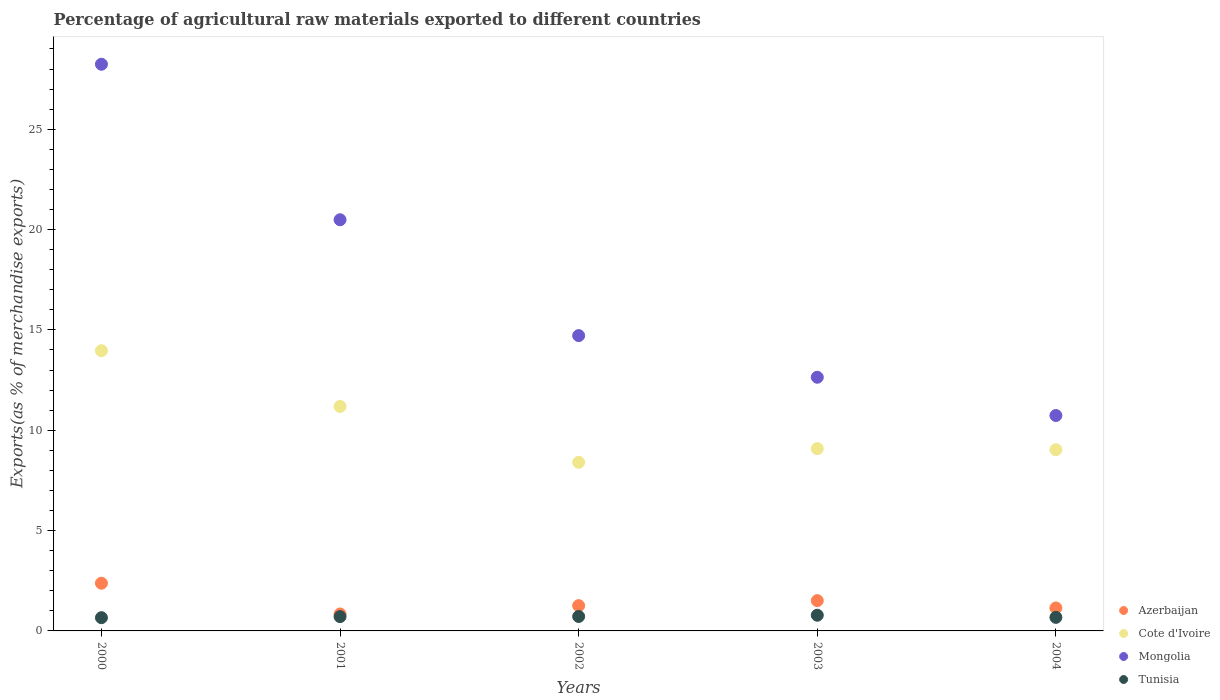How many different coloured dotlines are there?
Ensure brevity in your answer.  4. What is the percentage of exports to different countries in Tunisia in 2004?
Keep it short and to the point. 0.68. Across all years, what is the maximum percentage of exports to different countries in Azerbaijan?
Your response must be concise. 2.38. Across all years, what is the minimum percentage of exports to different countries in Tunisia?
Your answer should be compact. 0.66. What is the total percentage of exports to different countries in Cote d'Ivoire in the graph?
Give a very brief answer. 51.66. What is the difference between the percentage of exports to different countries in Azerbaijan in 2000 and that in 2003?
Ensure brevity in your answer.  0.87. What is the difference between the percentage of exports to different countries in Azerbaijan in 2001 and the percentage of exports to different countries in Cote d'Ivoire in 2000?
Ensure brevity in your answer.  -13.12. What is the average percentage of exports to different countries in Cote d'Ivoire per year?
Keep it short and to the point. 10.33. In the year 2001, what is the difference between the percentage of exports to different countries in Cote d'Ivoire and percentage of exports to different countries in Tunisia?
Ensure brevity in your answer.  10.47. What is the ratio of the percentage of exports to different countries in Cote d'Ivoire in 2002 to that in 2004?
Give a very brief answer. 0.93. Is the percentage of exports to different countries in Tunisia in 2000 less than that in 2003?
Provide a short and direct response. Yes. What is the difference between the highest and the second highest percentage of exports to different countries in Tunisia?
Provide a short and direct response. 0.06. What is the difference between the highest and the lowest percentage of exports to different countries in Cote d'Ivoire?
Give a very brief answer. 5.56. Is the sum of the percentage of exports to different countries in Tunisia in 2001 and 2004 greater than the maximum percentage of exports to different countries in Mongolia across all years?
Make the answer very short. No. Is it the case that in every year, the sum of the percentage of exports to different countries in Tunisia and percentage of exports to different countries in Cote d'Ivoire  is greater than the sum of percentage of exports to different countries in Mongolia and percentage of exports to different countries in Azerbaijan?
Make the answer very short. Yes. Is it the case that in every year, the sum of the percentage of exports to different countries in Cote d'Ivoire and percentage of exports to different countries in Mongolia  is greater than the percentage of exports to different countries in Tunisia?
Offer a terse response. Yes. How many dotlines are there?
Ensure brevity in your answer.  4. What is the difference between two consecutive major ticks on the Y-axis?
Your answer should be compact. 5. Does the graph contain any zero values?
Make the answer very short. No. Does the graph contain grids?
Make the answer very short. No. Where does the legend appear in the graph?
Keep it short and to the point. Bottom right. How many legend labels are there?
Your response must be concise. 4. What is the title of the graph?
Your answer should be very brief. Percentage of agricultural raw materials exported to different countries. Does "Czech Republic" appear as one of the legend labels in the graph?
Give a very brief answer. No. What is the label or title of the Y-axis?
Provide a succinct answer. Exports(as % of merchandise exports). What is the Exports(as % of merchandise exports) in Azerbaijan in 2000?
Provide a succinct answer. 2.38. What is the Exports(as % of merchandise exports) in Cote d'Ivoire in 2000?
Your answer should be very brief. 13.97. What is the Exports(as % of merchandise exports) of Mongolia in 2000?
Provide a succinct answer. 28.24. What is the Exports(as % of merchandise exports) in Tunisia in 2000?
Offer a very short reply. 0.66. What is the Exports(as % of merchandise exports) in Azerbaijan in 2001?
Give a very brief answer. 0.85. What is the Exports(as % of merchandise exports) of Cote d'Ivoire in 2001?
Provide a short and direct response. 11.18. What is the Exports(as % of merchandise exports) of Mongolia in 2001?
Ensure brevity in your answer.  20.49. What is the Exports(as % of merchandise exports) of Tunisia in 2001?
Provide a succinct answer. 0.71. What is the Exports(as % of merchandise exports) of Azerbaijan in 2002?
Your response must be concise. 1.26. What is the Exports(as % of merchandise exports) of Cote d'Ivoire in 2002?
Give a very brief answer. 8.4. What is the Exports(as % of merchandise exports) in Mongolia in 2002?
Give a very brief answer. 14.72. What is the Exports(as % of merchandise exports) of Tunisia in 2002?
Ensure brevity in your answer.  0.72. What is the Exports(as % of merchandise exports) in Azerbaijan in 2003?
Offer a very short reply. 1.51. What is the Exports(as % of merchandise exports) of Cote d'Ivoire in 2003?
Give a very brief answer. 9.08. What is the Exports(as % of merchandise exports) in Mongolia in 2003?
Keep it short and to the point. 12.64. What is the Exports(as % of merchandise exports) in Tunisia in 2003?
Offer a very short reply. 0.78. What is the Exports(as % of merchandise exports) in Azerbaijan in 2004?
Provide a short and direct response. 1.15. What is the Exports(as % of merchandise exports) in Cote d'Ivoire in 2004?
Make the answer very short. 9.03. What is the Exports(as % of merchandise exports) of Mongolia in 2004?
Your answer should be very brief. 10.73. What is the Exports(as % of merchandise exports) in Tunisia in 2004?
Make the answer very short. 0.68. Across all years, what is the maximum Exports(as % of merchandise exports) in Azerbaijan?
Keep it short and to the point. 2.38. Across all years, what is the maximum Exports(as % of merchandise exports) in Cote d'Ivoire?
Offer a very short reply. 13.97. Across all years, what is the maximum Exports(as % of merchandise exports) in Mongolia?
Offer a terse response. 28.24. Across all years, what is the maximum Exports(as % of merchandise exports) in Tunisia?
Your answer should be very brief. 0.78. Across all years, what is the minimum Exports(as % of merchandise exports) in Azerbaijan?
Your response must be concise. 0.85. Across all years, what is the minimum Exports(as % of merchandise exports) in Cote d'Ivoire?
Keep it short and to the point. 8.4. Across all years, what is the minimum Exports(as % of merchandise exports) of Mongolia?
Give a very brief answer. 10.73. Across all years, what is the minimum Exports(as % of merchandise exports) in Tunisia?
Your response must be concise. 0.66. What is the total Exports(as % of merchandise exports) of Azerbaijan in the graph?
Make the answer very short. 7.14. What is the total Exports(as % of merchandise exports) in Cote d'Ivoire in the graph?
Offer a very short reply. 51.66. What is the total Exports(as % of merchandise exports) of Mongolia in the graph?
Make the answer very short. 86.82. What is the total Exports(as % of merchandise exports) of Tunisia in the graph?
Ensure brevity in your answer.  3.55. What is the difference between the Exports(as % of merchandise exports) of Azerbaijan in 2000 and that in 2001?
Your response must be concise. 1.53. What is the difference between the Exports(as % of merchandise exports) of Cote d'Ivoire in 2000 and that in 2001?
Provide a succinct answer. 2.78. What is the difference between the Exports(as % of merchandise exports) of Mongolia in 2000 and that in 2001?
Offer a very short reply. 7.75. What is the difference between the Exports(as % of merchandise exports) of Tunisia in 2000 and that in 2001?
Your answer should be compact. -0.05. What is the difference between the Exports(as % of merchandise exports) of Azerbaijan in 2000 and that in 2002?
Offer a terse response. 1.12. What is the difference between the Exports(as % of merchandise exports) of Cote d'Ivoire in 2000 and that in 2002?
Keep it short and to the point. 5.56. What is the difference between the Exports(as % of merchandise exports) in Mongolia in 2000 and that in 2002?
Provide a succinct answer. 13.52. What is the difference between the Exports(as % of merchandise exports) in Tunisia in 2000 and that in 2002?
Ensure brevity in your answer.  -0.06. What is the difference between the Exports(as % of merchandise exports) of Azerbaijan in 2000 and that in 2003?
Keep it short and to the point. 0.87. What is the difference between the Exports(as % of merchandise exports) in Cote d'Ivoire in 2000 and that in 2003?
Your answer should be compact. 4.88. What is the difference between the Exports(as % of merchandise exports) of Mongolia in 2000 and that in 2003?
Keep it short and to the point. 15.6. What is the difference between the Exports(as % of merchandise exports) of Tunisia in 2000 and that in 2003?
Your response must be concise. -0.12. What is the difference between the Exports(as % of merchandise exports) in Azerbaijan in 2000 and that in 2004?
Give a very brief answer. 1.23. What is the difference between the Exports(as % of merchandise exports) in Cote d'Ivoire in 2000 and that in 2004?
Offer a terse response. 4.94. What is the difference between the Exports(as % of merchandise exports) in Mongolia in 2000 and that in 2004?
Your answer should be very brief. 17.5. What is the difference between the Exports(as % of merchandise exports) of Tunisia in 2000 and that in 2004?
Your answer should be compact. -0.02. What is the difference between the Exports(as % of merchandise exports) in Azerbaijan in 2001 and that in 2002?
Ensure brevity in your answer.  -0.41. What is the difference between the Exports(as % of merchandise exports) in Cote d'Ivoire in 2001 and that in 2002?
Ensure brevity in your answer.  2.78. What is the difference between the Exports(as % of merchandise exports) in Mongolia in 2001 and that in 2002?
Offer a very short reply. 5.77. What is the difference between the Exports(as % of merchandise exports) in Tunisia in 2001 and that in 2002?
Your answer should be compact. -0.01. What is the difference between the Exports(as % of merchandise exports) of Azerbaijan in 2001 and that in 2003?
Offer a terse response. -0.66. What is the difference between the Exports(as % of merchandise exports) in Cote d'Ivoire in 2001 and that in 2003?
Keep it short and to the point. 2.1. What is the difference between the Exports(as % of merchandise exports) in Mongolia in 2001 and that in 2003?
Your answer should be very brief. 7.85. What is the difference between the Exports(as % of merchandise exports) in Tunisia in 2001 and that in 2003?
Offer a very short reply. -0.07. What is the difference between the Exports(as % of merchandise exports) of Azerbaijan in 2001 and that in 2004?
Provide a short and direct response. -0.3. What is the difference between the Exports(as % of merchandise exports) of Cote d'Ivoire in 2001 and that in 2004?
Your answer should be very brief. 2.16. What is the difference between the Exports(as % of merchandise exports) of Mongolia in 2001 and that in 2004?
Your response must be concise. 9.75. What is the difference between the Exports(as % of merchandise exports) in Tunisia in 2001 and that in 2004?
Make the answer very short. 0.04. What is the difference between the Exports(as % of merchandise exports) of Azerbaijan in 2002 and that in 2003?
Offer a very short reply. -0.25. What is the difference between the Exports(as % of merchandise exports) in Cote d'Ivoire in 2002 and that in 2003?
Your answer should be compact. -0.68. What is the difference between the Exports(as % of merchandise exports) in Mongolia in 2002 and that in 2003?
Your response must be concise. 2.08. What is the difference between the Exports(as % of merchandise exports) in Tunisia in 2002 and that in 2003?
Make the answer very short. -0.06. What is the difference between the Exports(as % of merchandise exports) in Azerbaijan in 2002 and that in 2004?
Offer a very short reply. 0.11. What is the difference between the Exports(as % of merchandise exports) of Cote d'Ivoire in 2002 and that in 2004?
Your answer should be very brief. -0.63. What is the difference between the Exports(as % of merchandise exports) of Mongolia in 2002 and that in 2004?
Your answer should be compact. 3.98. What is the difference between the Exports(as % of merchandise exports) of Tunisia in 2002 and that in 2004?
Ensure brevity in your answer.  0.04. What is the difference between the Exports(as % of merchandise exports) in Azerbaijan in 2003 and that in 2004?
Your answer should be compact. 0.36. What is the difference between the Exports(as % of merchandise exports) in Cote d'Ivoire in 2003 and that in 2004?
Provide a short and direct response. 0.06. What is the difference between the Exports(as % of merchandise exports) of Mongolia in 2003 and that in 2004?
Your response must be concise. 1.91. What is the difference between the Exports(as % of merchandise exports) of Tunisia in 2003 and that in 2004?
Keep it short and to the point. 0.11. What is the difference between the Exports(as % of merchandise exports) in Azerbaijan in 2000 and the Exports(as % of merchandise exports) in Cote d'Ivoire in 2001?
Provide a short and direct response. -8.81. What is the difference between the Exports(as % of merchandise exports) of Azerbaijan in 2000 and the Exports(as % of merchandise exports) of Mongolia in 2001?
Give a very brief answer. -18.11. What is the difference between the Exports(as % of merchandise exports) in Azerbaijan in 2000 and the Exports(as % of merchandise exports) in Tunisia in 2001?
Provide a succinct answer. 1.66. What is the difference between the Exports(as % of merchandise exports) of Cote d'Ivoire in 2000 and the Exports(as % of merchandise exports) of Mongolia in 2001?
Your response must be concise. -6.52. What is the difference between the Exports(as % of merchandise exports) in Cote d'Ivoire in 2000 and the Exports(as % of merchandise exports) in Tunisia in 2001?
Offer a very short reply. 13.25. What is the difference between the Exports(as % of merchandise exports) of Mongolia in 2000 and the Exports(as % of merchandise exports) of Tunisia in 2001?
Your response must be concise. 27.52. What is the difference between the Exports(as % of merchandise exports) in Azerbaijan in 2000 and the Exports(as % of merchandise exports) in Cote d'Ivoire in 2002?
Give a very brief answer. -6.02. What is the difference between the Exports(as % of merchandise exports) of Azerbaijan in 2000 and the Exports(as % of merchandise exports) of Mongolia in 2002?
Offer a terse response. -12.34. What is the difference between the Exports(as % of merchandise exports) in Azerbaijan in 2000 and the Exports(as % of merchandise exports) in Tunisia in 2002?
Offer a terse response. 1.66. What is the difference between the Exports(as % of merchandise exports) in Cote d'Ivoire in 2000 and the Exports(as % of merchandise exports) in Mongolia in 2002?
Provide a short and direct response. -0.75. What is the difference between the Exports(as % of merchandise exports) in Cote d'Ivoire in 2000 and the Exports(as % of merchandise exports) in Tunisia in 2002?
Make the answer very short. 13.25. What is the difference between the Exports(as % of merchandise exports) in Mongolia in 2000 and the Exports(as % of merchandise exports) in Tunisia in 2002?
Give a very brief answer. 27.52. What is the difference between the Exports(as % of merchandise exports) in Azerbaijan in 2000 and the Exports(as % of merchandise exports) in Cote d'Ivoire in 2003?
Keep it short and to the point. -6.71. What is the difference between the Exports(as % of merchandise exports) in Azerbaijan in 2000 and the Exports(as % of merchandise exports) in Mongolia in 2003?
Keep it short and to the point. -10.26. What is the difference between the Exports(as % of merchandise exports) of Azerbaijan in 2000 and the Exports(as % of merchandise exports) of Tunisia in 2003?
Keep it short and to the point. 1.6. What is the difference between the Exports(as % of merchandise exports) in Cote d'Ivoire in 2000 and the Exports(as % of merchandise exports) in Mongolia in 2003?
Keep it short and to the point. 1.32. What is the difference between the Exports(as % of merchandise exports) in Cote d'Ivoire in 2000 and the Exports(as % of merchandise exports) in Tunisia in 2003?
Make the answer very short. 13.18. What is the difference between the Exports(as % of merchandise exports) of Mongolia in 2000 and the Exports(as % of merchandise exports) of Tunisia in 2003?
Provide a succinct answer. 27.46. What is the difference between the Exports(as % of merchandise exports) of Azerbaijan in 2000 and the Exports(as % of merchandise exports) of Cote d'Ivoire in 2004?
Your response must be concise. -6.65. What is the difference between the Exports(as % of merchandise exports) of Azerbaijan in 2000 and the Exports(as % of merchandise exports) of Mongolia in 2004?
Offer a very short reply. -8.36. What is the difference between the Exports(as % of merchandise exports) of Azerbaijan in 2000 and the Exports(as % of merchandise exports) of Tunisia in 2004?
Keep it short and to the point. 1.7. What is the difference between the Exports(as % of merchandise exports) of Cote d'Ivoire in 2000 and the Exports(as % of merchandise exports) of Mongolia in 2004?
Keep it short and to the point. 3.23. What is the difference between the Exports(as % of merchandise exports) of Cote d'Ivoire in 2000 and the Exports(as % of merchandise exports) of Tunisia in 2004?
Your answer should be compact. 13.29. What is the difference between the Exports(as % of merchandise exports) in Mongolia in 2000 and the Exports(as % of merchandise exports) in Tunisia in 2004?
Provide a succinct answer. 27.56. What is the difference between the Exports(as % of merchandise exports) in Azerbaijan in 2001 and the Exports(as % of merchandise exports) in Cote d'Ivoire in 2002?
Your answer should be very brief. -7.56. What is the difference between the Exports(as % of merchandise exports) in Azerbaijan in 2001 and the Exports(as % of merchandise exports) in Mongolia in 2002?
Offer a very short reply. -13.87. What is the difference between the Exports(as % of merchandise exports) in Azerbaijan in 2001 and the Exports(as % of merchandise exports) in Tunisia in 2002?
Keep it short and to the point. 0.13. What is the difference between the Exports(as % of merchandise exports) in Cote d'Ivoire in 2001 and the Exports(as % of merchandise exports) in Mongolia in 2002?
Offer a very short reply. -3.53. What is the difference between the Exports(as % of merchandise exports) in Cote d'Ivoire in 2001 and the Exports(as % of merchandise exports) in Tunisia in 2002?
Provide a succinct answer. 10.46. What is the difference between the Exports(as % of merchandise exports) in Mongolia in 2001 and the Exports(as % of merchandise exports) in Tunisia in 2002?
Give a very brief answer. 19.77. What is the difference between the Exports(as % of merchandise exports) of Azerbaijan in 2001 and the Exports(as % of merchandise exports) of Cote d'Ivoire in 2003?
Make the answer very short. -8.24. What is the difference between the Exports(as % of merchandise exports) of Azerbaijan in 2001 and the Exports(as % of merchandise exports) of Mongolia in 2003?
Offer a very short reply. -11.8. What is the difference between the Exports(as % of merchandise exports) in Azerbaijan in 2001 and the Exports(as % of merchandise exports) in Tunisia in 2003?
Ensure brevity in your answer.  0.06. What is the difference between the Exports(as % of merchandise exports) in Cote d'Ivoire in 2001 and the Exports(as % of merchandise exports) in Mongolia in 2003?
Offer a very short reply. -1.46. What is the difference between the Exports(as % of merchandise exports) of Cote d'Ivoire in 2001 and the Exports(as % of merchandise exports) of Tunisia in 2003?
Make the answer very short. 10.4. What is the difference between the Exports(as % of merchandise exports) in Mongolia in 2001 and the Exports(as % of merchandise exports) in Tunisia in 2003?
Keep it short and to the point. 19.71. What is the difference between the Exports(as % of merchandise exports) in Azerbaijan in 2001 and the Exports(as % of merchandise exports) in Cote d'Ivoire in 2004?
Your answer should be very brief. -8.18. What is the difference between the Exports(as % of merchandise exports) in Azerbaijan in 2001 and the Exports(as % of merchandise exports) in Mongolia in 2004?
Make the answer very short. -9.89. What is the difference between the Exports(as % of merchandise exports) of Azerbaijan in 2001 and the Exports(as % of merchandise exports) of Tunisia in 2004?
Offer a very short reply. 0.17. What is the difference between the Exports(as % of merchandise exports) of Cote d'Ivoire in 2001 and the Exports(as % of merchandise exports) of Mongolia in 2004?
Offer a very short reply. 0.45. What is the difference between the Exports(as % of merchandise exports) of Cote d'Ivoire in 2001 and the Exports(as % of merchandise exports) of Tunisia in 2004?
Keep it short and to the point. 10.51. What is the difference between the Exports(as % of merchandise exports) of Mongolia in 2001 and the Exports(as % of merchandise exports) of Tunisia in 2004?
Give a very brief answer. 19.81. What is the difference between the Exports(as % of merchandise exports) in Azerbaijan in 2002 and the Exports(as % of merchandise exports) in Cote d'Ivoire in 2003?
Your answer should be very brief. -7.82. What is the difference between the Exports(as % of merchandise exports) of Azerbaijan in 2002 and the Exports(as % of merchandise exports) of Mongolia in 2003?
Your answer should be very brief. -11.38. What is the difference between the Exports(as % of merchandise exports) of Azerbaijan in 2002 and the Exports(as % of merchandise exports) of Tunisia in 2003?
Offer a very short reply. 0.48. What is the difference between the Exports(as % of merchandise exports) of Cote d'Ivoire in 2002 and the Exports(as % of merchandise exports) of Mongolia in 2003?
Offer a very short reply. -4.24. What is the difference between the Exports(as % of merchandise exports) in Cote d'Ivoire in 2002 and the Exports(as % of merchandise exports) in Tunisia in 2003?
Offer a terse response. 7.62. What is the difference between the Exports(as % of merchandise exports) of Mongolia in 2002 and the Exports(as % of merchandise exports) of Tunisia in 2003?
Your response must be concise. 13.93. What is the difference between the Exports(as % of merchandise exports) in Azerbaijan in 2002 and the Exports(as % of merchandise exports) in Cote d'Ivoire in 2004?
Make the answer very short. -7.77. What is the difference between the Exports(as % of merchandise exports) of Azerbaijan in 2002 and the Exports(as % of merchandise exports) of Mongolia in 2004?
Provide a short and direct response. -9.47. What is the difference between the Exports(as % of merchandise exports) in Azerbaijan in 2002 and the Exports(as % of merchandise exports) in Tunisia in 2004?
Make the answer very short. 0.58. What is the difference between the Exports(as % of merchandise exports) of Cote d'Ivoire in 2002 and the Exports(as % of merchandise exports) of Mongolia in 2004?
Give a very brief answer. -2.33. What is the difference between the Exports(as % of merchandise exports) in Cote d'Ivoire in 2002 and the Exports(as % of merchandise exports) in Tunisia in 2004?
Your response must be concise. 7.73. What is the difference between the Exports(as % of merchandise exports) of Mongolia in 2002 and the Exports(as % of merchandise exports) of Tunisia in 2004?
Provide a short and direct response. 14.04. What is the difference between the Exports(as % of merchandise exports) of Azerbaijan in 2003 and the Exports(as % of merchandise exports) of Cote d'Ivoire in 2004?
Your answer should be compact. -7.52. What is the difference between the Exports(as % of merchandise exports) of Azerbaijan in 2003 and the Exports(as % of merchandise exports) of Mongolia in 2004?
Keep it short and to the point. -9.22. What is the difference between the Exports(as % of merchandise exports) of Azerbaijan in 2003 and the Exports(as % of merchandise exports) of Tunisia in 2004?
Your response must be concise. 0.83. What is the difference between the Exports(as % of merchandise exports) in Cote d'Ivoire in 2003 and the Exports(as % of merchandise exports) in Mongolia in 2004?
Keep it short and to the point. -1.65. What is the difference between the Exports(as % of merchandise exports) of Cote d'Ivoire in 2003 and the Exports(as % of merchandise exports) of Tunisia in 2004?
Offer a very short reply. 8.41. What is the difference between the Exports(as % of merchandise exports) in Mongolia in 2003 and the Exports(as % of merchandise exports) in Tunisia in 2004?
Offer a terse response. 11.96. What is the average Exports(as % of merchandise exports) in Azerbaijan per year?
Ensure brevity in your answer.  1.43. What is the average Exports(as % of merchandise exports) in Cote d'Ivoire per year?
Provide a succinct answer. 10.33. What is the average Exports(as % of merchandise exports) in Mongolia per year?
Make the answer very short. 17.36. What is the average Exports(as % of merchandise exports) in Tunisia per year?
Keep it short and to the point. 0.71. In the year 2000, what is the difference between the Exports(as % of merchandise exports) in Azerbaijan and Exports(as % of merchandise exports) in Cote d'Ivoire?
Offer a very short reply. -11.59. In the year 2000, what is the difference between the Exports(as % of merchandise exports) of Azerbaijan and Exports(as % of merchandise exports) of Mongolia?
Your answer should be compact. -25.86. In the year 2000, what is the difference between the Exports(as % of merchandise exports) of Azerbaijan and Exports(as % of merchandise exports) of Tunisia?
Make the answer very short. 1.72. In the year 2000, what is the difference between the Exports(as % of merchandise exports) of Cote d'Ivoire and Exports(as % of merchandise exports) of Mongolia?
Your response must be concise. -14.27. In the year 2000, what is the difference between the Exports(as % of merchandise exports) in Cote d'Ivoire and Exports(as % of merchandise exports) in Tunisia?
Your answer should be compact. 13.31. In the year 2000, what is the difference between the Exports(as % of merchandise exports) in Mongolia and Exports(as % of merchandise exports) in Tunisia?
Keep it short and to the point. 27.58. In the year 2001, what is the difference between the Exports(as % of merchandise exports) of Azerbaijan and Exports(as % of merchandise exports) of Cote d'Ivoire?
Ensure brevity in your answer.  -10.34. In the year 2001, what is the difference between the Exports(as % of merchandise exports) of Azerbaijan and Exports(as % of merchandise exports) of Mongolia?
Provide a short and direct response. -19.64. In the year 2001, what is the difference between the Exports(as % of merchandise exports) in Azerbaijan and Exports(as % of merchandise exports) in Tunisia?
Make the answer very short. 0.13. In the year 2001, what is the difference between the Exports(as % of merchandise exports) of Cote d'Ivoire and Exports(as % of merchandise exports) of Mongolia?
Give a very brief answer. -9.3. In the year 2001, what is the difference between the Exports(as % of merchandise exports) in Cote d'Ivoire and Exports(as % of merchandise exports) in Tunisia?
Keep it short and to the point. 10.47. In the year 2001, what is the difference between the Exports(as % of merchandise exports) of Mongolia and Exports(as % of merchandise exports) of Tunisia?
Provide a short and direct response. 19.78. In the year 2002, what is the difference between the Exports(as % of merchandise exports) in Azerbaijan and Exports(as % of merchandise exports) in Cote d'Ivoire?
Your answer should be very brief. -7.14. In the year 2002, what is the difference between the Exports(as % of merchandise exports) of Azerbaijan and Exports(as % of merchandise exports) of Mongolia?
Provide a succinct answer. -13.46. In the year 2002, what is the difference between the Exports(as % of merchandise exports) of Azerbaijan and Exports(as % of merchandise exports) of Tunisia?
Give a very brief answer. 0.54. In the year 2002, what is the difference between the Exports(as % of merchandise exports) in Cote d'Ivoire and Exports(as % of merchandise exports) in Mongolia?
Offer a terse response. -6.31. In the year 2002, what is the difference between the Exports(as % of merchandise exports) of Cote d'Ivoire and Exports(as % of merchandise exports) of Tunisia?
Make the answer very short. 7.68. In the year 2002, what is the difference between the Exports(as % of merchandise exports) of Mongolia and Exports(as % of merchandise exports) of Tunisia?
Make the answer very short. 14. In the year 2003, what is the difference between the Exports(as % of merchandise exports) in Azerbaijan and Exports(as % of merchandise exports) in Cote d'Ivoire?
Your response must be concise. -7.58. In the year 2003, what is the difference between the Exports(as % of merchandise exports) of Azerbaijan and Exports(as % of merchandise exports) of Mongolia?
Ensure brevity in your answer.  -11.13. In the year 2003, what is the difference between the Exports(as % of merchandise exports) of Azerbaijan and Exports(as % of merchandise exports) of Tunisia?
Provide a succinct answer. 0.73. In the year 2003, what is the difference between the Exports(as % of merchandise exports) of Cote d'Ivoire and Exports(as % of merchandise exports) of Mongolia?
Provide a short and direct response. -3.56. In the year 2003, what is the difference between the Exports(as % of merchandise exports) of Cote d'Ivoire and Exports(as % of merchandise exports) of Tunisia?
Offer a terse response. 8.3. In the year 2003, what is the difference between the Exports(as % of merchandise exports) of Mongolia and Exports(as % of merchandise exports) of Tunisia?
Ensure brevity in your answer.  11.86. In the year 2004, what is the difference between the Exports(as % of merchandise exports) of Azerbaijan and Exports(as % of merchandise exports) of Cote d'Ivoire?
Provide a short and direct response. -7.88. In the year 2004, what is the difference between the Exports(as % of merchandise exports) of Azerbaijan and Exports(as % of merchandise exports) of Mongolia?
Offer a terse response. -9.59. In the year 2004, what is the difference between the Exports(as % of merchandise exports) in Azerbaijan and Exports(as % of merchandise exports) in Tunisia?
Your answer should be very brief. 0.47. In the year 2004, what is the difference between the Exports(as % of merchandise exports) of Cote d'Ivoire and Exports(as % of merchandise exports) of Mongolia?
Your response must be concise. -1.71. In the year 2004, what is the difference between the Exports(as % of merchandise exports) of Cote d'Ivoire and Exports(as % of merchandise exports) of Tunisia?
Make the answer very short. 8.35. In the year 2004, what is the difference between the Exports(as % of merchandise exports) in Mongolia and Exports(as % of merchandise exports) in Tunisia?
Offer a terse response. 10.06. What is the ratio of the Exports(as % of merchandise exports) of Azerbaijan in 2000 to that in 2001?
Your answer should be very brief. 2.81. What is the ratio of the Exports(as % of merchandise exports) in Cote d'Ivoire in 2000 to that in 2001?
Provide a short and direct response. 1.25. What is the ratio of the Exports(as % of merchandise exports) in Mongolia in 2000 to that in 2001?
Your answer should be compact. 1.38. What is the ratio of the Exports(as % of merchandise exports) of Tunisia in 2000 to that in 2001?
Provide a succinct answer. 0.92. What is the ratio of the Exports(as % of merchandise exports) of Azerbaijan in 2000 to that in 2002?
Your answer should be very brief. 1.89. What is the ratio of the Exports(as % of merchandise exports) of Cote d'Ivoire in 2000 to that in 2002?
Ensure brevity in your answer.  1.66. What is the ratio of the Exports(as % of merchandise exports) in Mongolia in 2000 to that in 2002?
Offer a terse response. 1.92. What is the ratio of the Exports(as % of merchandise exports) in Tunisia in 2000 to that in 2002?
Make the answer very short. 0.92. What is the ratio of the Exports(as % of merchandise exports) in Azerbaijan in 2000 to that in 2003?
Provide a short and direct response. 1.58. What is the ratio of the Exports(as % of merchandise exports) in Cote d'Ivoire in 2000 to that in 2003?
Provide a short and direct response. 1.54. What is the ratio of the Exports(as % of merchandise exports) of Mongolia in 2000 to that in 2003?
Your answer should be compact. 2.23. What is the ratio of the Exports(as % of merchandise exports) in Tunisia in 2000 to that in 2003?
Provide a short and direct response. 0.84. What is the ratio of the Exports(as % of merchandise exports) of Azerbaijan in 2000 to that in 2004?
Your response must be concise. 2.08. What is the ratio of the Exports(as % of merchandise exports) in Cote d'Ivoire in 2000 to that in 2004?
Provide a succinct answer. 1.55. What is the ratio of the Exports(as % of merchandise exports) in Mongolia in 2000 to that in 2004?
Offer a terse response. 2.63. What is the ratio of the Exports(as % of merchandise exports) in Tunisia in 2000 to that in 2004?
Offer a very short reply. 0.98. What is the ratio of the Exports(as % of merchandise exports) in Azerbaijan in 2001 to that in 2002?
Provide a succinct answer. 0.67. What is the ratio of the Exports(as % of merchandise exports) in Cote d'Ivoire in 2001 to that in 2002?
Provide a succinct answer. 1.33. What is the ratio of the Exports(as % of merchandise exports) of Mongolia in 2001 to that in 2002?
Your response must be concise. 1.39. What is the ratio of the Exports(as % of merchandise exports) in Azerbaijan in 2001 to that in 2003?
Offer a very short reply. 0.56. What is the ratio of the Exports(as % of merchandise exports) of Cote d'Ivoire in 2001 to that in 2003?
Your answer should be compact. 1.23. What is the ratio of the Exports(as % of merchandise exports) in Mongolia in 2001 to that in 2003?
Ensure brevity in your answer.  1.62. What is the ratio of the Exports(as % of merchandise exports) in Tunisia in 2001 to that in 2003?
Provide a short and direct response. 0.91. What is the ratio of the Exports(as % of merchandise exports) of Azerbaijan in 2001 to that in 2004?
Offer a very short reply. 0.74. What is the ratio of the Exports(as % of merchandise exports) in Cote d'Ivoire in 2001 to that in 2004?
Provide a short and direct response. 1.24. What is the ratio of the Exports(as % of merchandise exports) of Mongolia in 2001 to that in 2004?
Your response must be concise. 1.91. What is the ratio of the Exports(as % of merchandise exports) in Tunisia in 2001 to that in 2004?
Ensure brevity in your answer.  1.05. What is the ratio of the Exports(as % of merchandise exports) of Azerbaijan in 2002 to that in 2003?
Provide a short and direct response. 0.83. What is the ratio of the Exports(as % of merchandise exports) of Cote d'Ivoire in 2002 to that in 2003?
Your response must be concise. 0.92. What is the ratio of the Exports(as % of merchandise exports) of Mongolia in 2002 to that in 2003?
Offer a terse response. 1.16. What is the ratio of the Exports(as % of merchandise exports) in Tunisia in 2002 to that in 2003?
Provide a succinct answer. 0.92. What is the ratio of the Exports(as % of merchandise exports) of Azerbaijan in 2002 to that in 2004?
Your answer should be compact. 1.1. What is the ratio of the Exports(as % of merchandise exports) of Cote d'Ivoire in 2002 to that in 2004?
Provide a short and direct response. 0.93. What is the ratio of the Exports(as % of merchandise exports) in Mongolia in 2002 to that in 2004?
Keep it short and to the point. 1.37. What is the ratio of the Exports(as % of merchandise exports) of Tunisia in 2002 to that in 2004?
Keep it short and to the point. 1.06. What is the ratio of the Exports(as % of merchandise exports) in Azerbaijan in 2003 to that in 2004?
Offer a terse response. 1.32. What is the ratio of the Exports(as % of merchandise exports) in Cote d'Ivoire in 2003 to that in 2004?
Provide a short and direct response. 1.01. What is the ratio of the Exports(as % of merchandise exports) of Mongolia in 2003 to that in 2004?
Your answer should be very brief. 1.18. What is the ratio of the Exports(as % of merchandise exports) in Tunisia in 2003 to that in 2004?
Give a very brief answer. 1.16. What is the difference between the highest and the second highest Exports(as % of merchandise exports) in Azerbaijan?
Your answer should be very brief. 0.87. What is the difference between the highest and the second highest Exports(as % of merchandise exports) of Cote d'Ivoire?
Make the answer very short. 2.78. What is the difference between the highest and the second highest Exports(as % of merchandise exports) of Mongolia?
Provide a succinct answer. 7.75. What is the difference between the highest and the second highest Exports(as % of merchandise exports) of Tunisia?
Your response must be concise. 0.06. What is the difference between the highest and the lowest Exports(as % of merchandise exports) in Azerbaijan?
Provide a short and direct response. 1.53. What is the difference between the highest and the lowest Exports(as % of merchandise exports) in Cote d'Ivoire?
Your response must be concise. 5.56. What is the difference between the highest and the lowest Exports(as % of merchandise exports) of Mongolia?
Provide a short and direct response. 17.5. What is the difference between the highest and the lowest Exports(as % of merchandise exports) in Tunisia?
Provide a short and direct response. 0.12. 